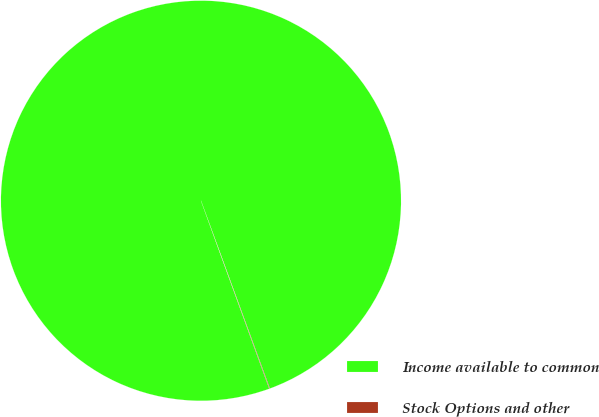<chart> <loc_0><loc_0><loc_500><loc_500><pie_chart><fcel>Income available to common<fcel>Stock Options and other<nl><fcel>99.96%<fcel>0.04%<nl></chart> 